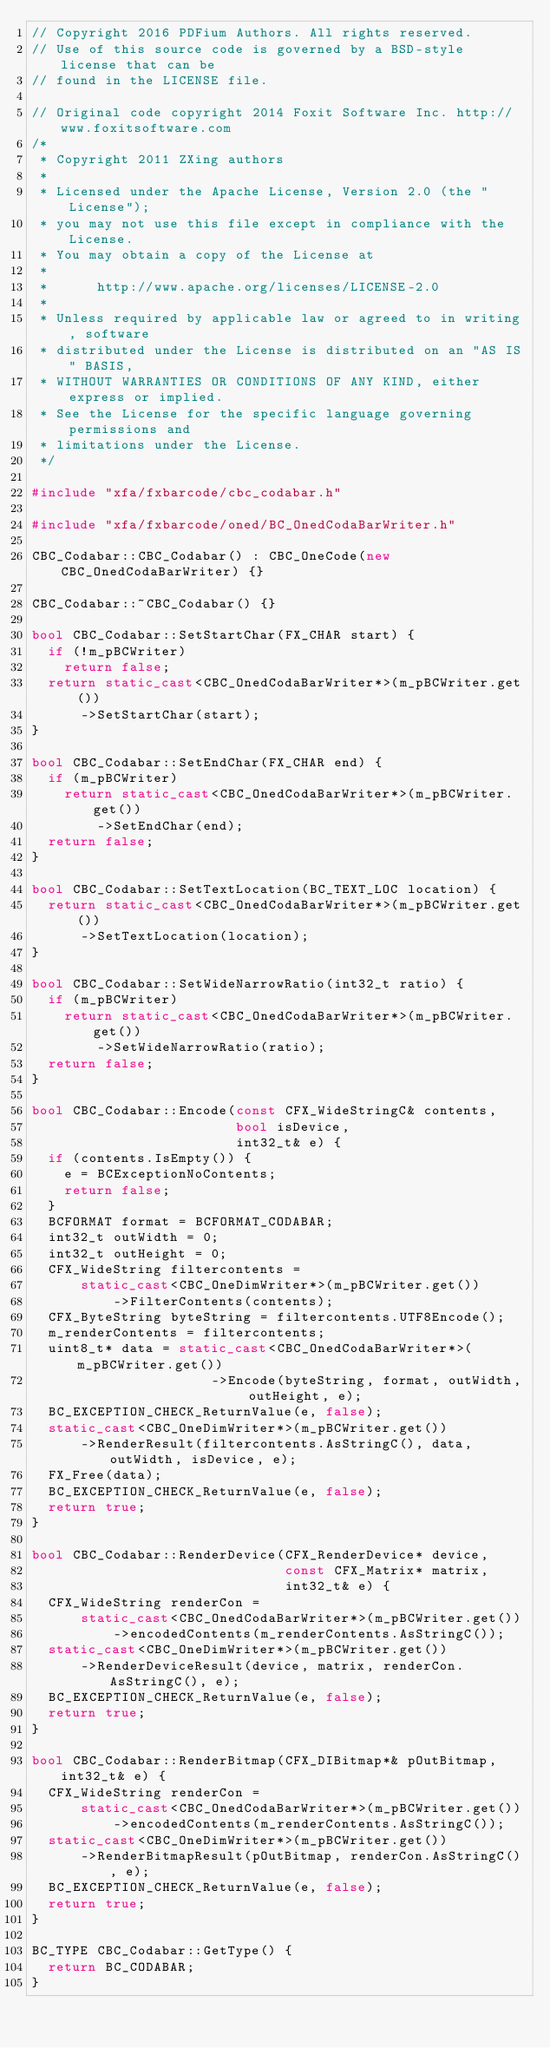Convert code to text. <code><loc_0><loc_0><loc_500><loc_500><_C++_>// Copyright 2016 PDFium Authors. All rights reserved.
// Use of this source code is governed by a BSD-style license that can be
// found in the LICENSE file.

// Original code copyright 2014 Foxit Software Inc. http://www.foxitsoftware.com
/*
 * Copyright 2011 ZXing authors
 *
 * Licensed under the Apache License, Version 2.0 (the "License");
 * you may not use this file except in compliance with the License.
 * You may obtain a copy of the License at
 *
 *      http://www.apache.org/licenses/LICENSE-2.0
 *
 * Unless required by applicable law or agreed to in writing, software
 * distributed under the License is distributed on an "AS IS" BASIS,
 * WITHOUT WARRANTIES OR CONDITIONS OF ANY KIND, either express or implied.
 * See the License for the specific language governing permissions and
 * limitations under the License.
 */

#include "xfa/fxbarcode/cbc_codabar.h"

#include "xfa/fxbarcode/oned/BC_OnedCodaBarWriter.h"

CBC_Codabar::CBC_Codabar() : CBC_OneCode(new CBC_OnedCodaBarWriter) {}

CBC_Codabar::~CBC_Codabar() {}

bool CBC_Codabar::SetStartChar(FX_CHAR start) {
  if (!m_pBCWriter)
    return false;
  return static_cast<CBC_OnedCodaBarWriter*>(m_pBCWriter.get())
      ->SetStartChar(start);
}

bool CBC_Codabar::SetEndChar(FX_CHAR end) {
  if (m_pBCWriter)
    return static_cast<CBC_OnedCodaBarWriter*>(m_pBCWriter.get())
        ->SetEndChar(end);
  return false;
}

bool CBC_Codabar::SetTextLocation(BC_TEXT_LOC location) {
  return static_cast<CBC_OnedCodaBarWriter*>(m_pBCWriter.get())
      ->SetTextLocation(location);
}

bool CBC_Codabar::SetWideNarrowRatio(int32_t ratio) {
  if (m_pBCWriter)
    return static_cast<CBC_OnedCodaBarWriter*>(m_pBCWriter.get())
        ->SetWideNarrowRatio(ratio);
  return false;
}

bool CBC_Codabar::Encode(const CFX_WideStringC& contents,
                         bool isDevice,
                         int32_t& e) {
  if (contents.IsEmpty()) {
    e = BCExceptionNoContents;
    return false;
  }
  BCFORMAT format = BCFORMAT_CODABAR;
  int32_t outWidth = 0;
  int32_t outHeight = 0;
  CFX_WideString filtercontents =
      static_cast<CBC_OneDimWriter*>(m_pBCWriter.get())
          ->FilterContents(contents);
  CFX_ByteString byteString = filtercontents.UTF8Encode();
  m_renderContents = filtercontents;
  uint8_t* data = static_cast<CBC_OnedCodaBarWriter*>(m_pBCWriter.get())
                      ->Encode(byteString, format, outWidth, outHeight, e);
  BC_EXCEPTION_CHECK_ReturnValue(e, false);
  static_cast<CBC_OneDimWriter*>(m_pBCWriter.get())
      ->RenderResult(filtercontents.AsStringC(), data, outWidth, isDevice, e);
  FX_Free(data);
  BC_EXCEPTION_CHECK_ReturnValue(e, false);
  return true;
}

bool CBC_Codabar::RenderDevice(CFX_RenderDevice* device,
                               const CFX_Matrix* matrix,
                               int32_t& e) {
  CFX_WideString renderCon =
      static_cast<CBC_OnedCodaBarWriter*>(m_pBCWriter.get())
          ->encodedContents(m_renderContents.AsStringC());
  static_cast<CBC_OneDimWriter*>(m_pBCWriter.get())
      ->RenderDeviceResult(device, matrix, renderCon.AsStringC(), e);
  BC_EXCEPTION_CHECK_ReturnValue(e, false);
  return true;
}

bool CBC_Codabar::RenderBitmap(CFX_DIBitmap*& pOutBitmap, int32_t& e) {
  CFX_WideString renderCon =
      static_cast<CBC_OnedCodaBarWriter*>(m_pBCWriter.get())
          ->encodedContents(m_renderContents.AsStringC());
  static_cast<CBC_OneDimWriter*>(m_pBCWriter.get())
      ->RenderBitmapResult(pOutBitmap, renderCon.AsStringC(), e);
  BC_EXCEPTION_CHECK_ReturnValue(e, false);
  return true;
}

BC_TYPE CBC_Codabar::GetType() {
  return BC_CODABAR;
}
</code> 